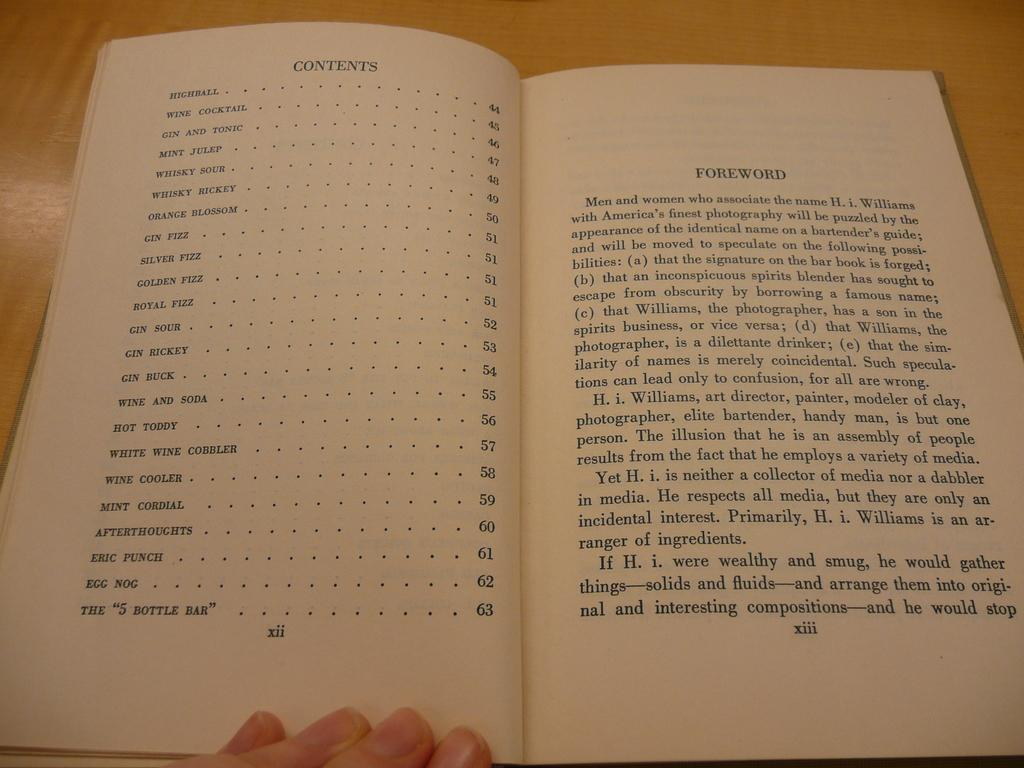Provide a one-sentence caption for the provided image. two book pages one listing contents and the other the foreword. 